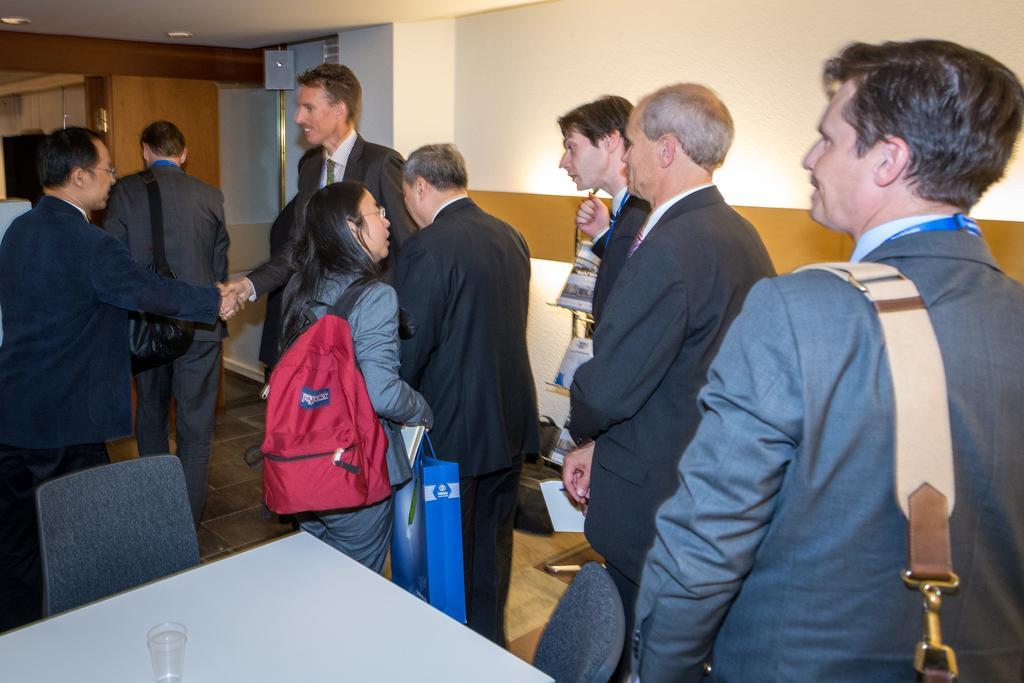In one or two sentences, can you explain what this image depicts? In this picture there are people in the center of the and there is a table, chair, and a glass at the bottom side of the image and there is a door in the background area of the image. 